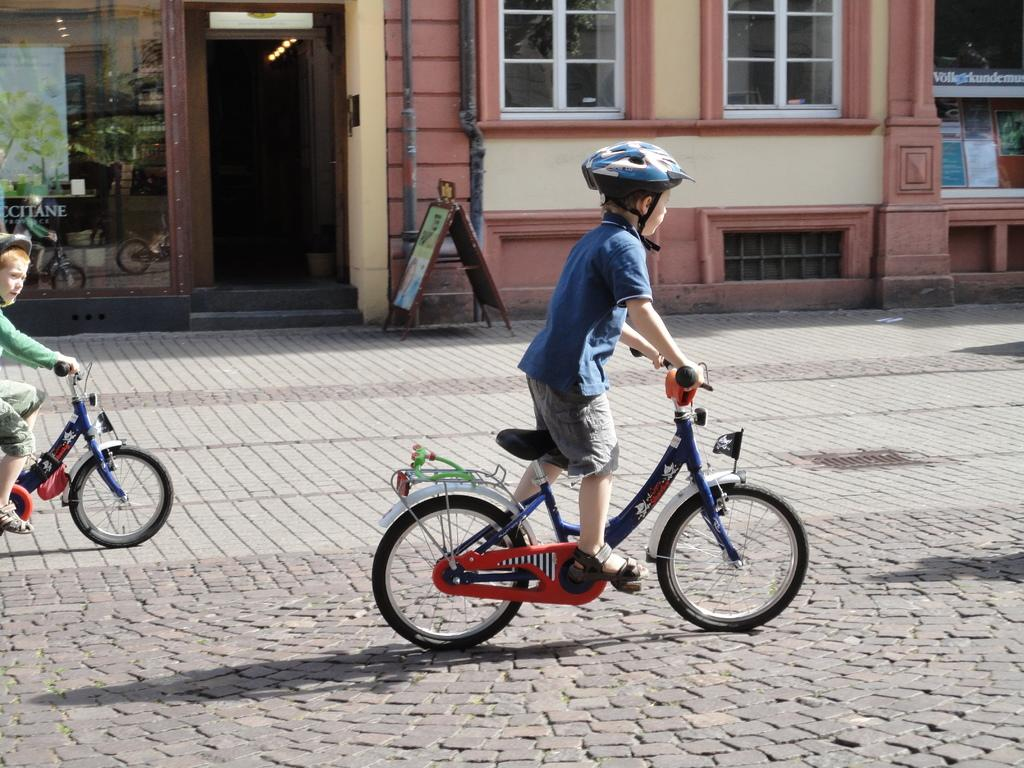How many boys are in the image? There are two boys in the image. What are the boys doing in the image? The boys are riding a cycle in the image. Where are the boys located in the image? The boys are on a road in the image. What can be seen in the background of the image? There is a big house in the background of the image, and the background appears sunny. What type of map is the boys using to navigate the road in the image? There is no map present in the image; the boys are simply riding a cycle on the road. What role does the governor play in the image? There is no governor present in the image; it features two boys riding a cycle on a road. 